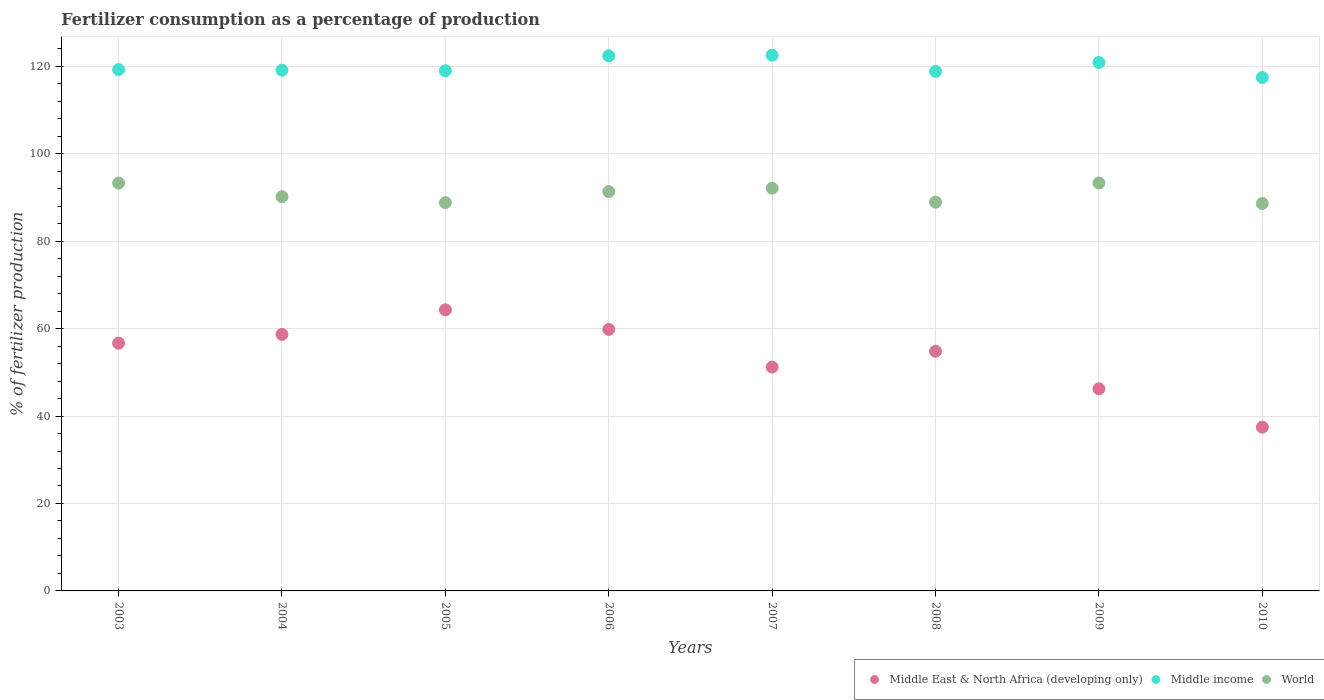Is the number of dotlines equal to the number of legend labels?
Give a very brief answer. Yes. What is the percentage of fertilizers consumed in World in 2007?
Offer a very short reply. 92.12. Across all years, what is the maximum percentage of fertilizers consumed in Middle East & North Africa (developing only)?
Your response must be concise. 64.3. Across all years, what is the minimum percentage of fertilizers consumed in Middle East & North Africa (developing only)?
Give a very brief answer. 37.45. In which year was the percentage of fertilizers consumed in Middle income maximum?
Offer a very short reply. 2007. What is the total percentage of fertilizers consumed in World in the graph?
Give a very brief answer. 726.58. What is the difference between the percentage of fertilizers consumed in World in 2003 and that in 2010?
Provide a short and direct response. 4.67. What is the difference between the percentage of fertilizers consumed in World in 2004 and the percentage of fertilizers consumed in Middle East & North Africa (developing only) in 2007?
Keep it short and to the point. 38.98. What is the average percentage of fertilizers consumed in World per year?
Your answer should be very brief. 90.82. In the year 2009, what is the difference between the percentage of fertilizers consumed in World and percentage of fertilizers consumed in Middle income?
Provide a short and direct response. -27.55. In how many years, is the percentage of fertilizers consumed in Middle East & North Africa (developing only) greater than 88 %?
Your answer should be compact. 0. What is the ratio of the percentage of fertilizers consumed in Middle East & North Africa (developing only) in 2004 to that in 2010?
Your response must be concise. 1.57. Is the percentage of fertilizers consumed in World in 2007 less than that in 2010?
Make the answer very short. No. Is the difference between the percentage of fertilizers consumed in World in 2007 and 2008 greater than the difference between the percentage of fertilizers consumed in Middle income in 2007 and 2008?
Offer a terse response. No. What is the difference between the highest and the second highest percentage of fertilizers consumed in World?
Your response must be concise. 0.04. What is the difference between the highest and the lowest percentage of fertilizers consumed in Middle East & North Africa (developing only)?
Your answer should be compact. 26.85. Does the percentage of fertilizers consumed in Middle income monotonically increase over the years?
Keep it short and to the point. No. Is the percentage of fertilizers consumed in World strictly greater than the percentage of fertilizers consumed in Middle East & North Africa (developing only) over the years?
Your response must be concise. Yes. How many dotlines are there?
Ensure brevity in your answer.  3. How many years are there in the graph?
Your answer should be very brief. 8. Does the graph contain grids?
Provide a short and direct response. Yes. How many legend labels are there?
Provide a short and direct response. 3. How are the legend labels stacked?
Your answer should be compact. Horizontal. What is the title of the graph?
Your answer should be very brief. Fertilizer consumption as a percentage of production. What is the label or title of the X-axis?
Offer a terse response. Years. What is the label or title of the Y-axis?
Provide a short and direct response. % of fertilizer production. What is the % of fertilizer production of Middle East & North Africa (developing only) in 2003?
Offer a very short reply. 56.66. What is the % of fertilizer production in Middle income in 2003?
Offer a terse response. 119.25. What is the % of fertilizer production in World in 2003?
Ensure brevity in your answer.  93.27. What is the % of fertilizer production in Middle East & North Africa (developing only) in 2004?
Make the answer very short. 58.68. What is the % of fertilizer production in Middle income in 2004?
Your answer should be compact. 119.11. What is the % of fertilizer production in World in 2004?
Give a very brief answer. 90.18. What is the % of fertilizer production in Middle East & North Africa (developing only) in 2005?
Offer a terse response. 64.3. What is the % of fertilizer production in Middle income in 2005?
Provide a succinct answer. 118.99. What is the % of fertilizer production of World in 2005?
Your answer should be compact. 88.81. What is the % of fertilizer production in Middle East & North Africa (developing only) in 2006?
Offer a very short reply. 59.82. What is the % of fertilizer production in Middle income in 2006?
Provide a succinct answer. 122.4. What is the % of fertilizer production of World in 2006?
Make the answer very short. 91.34. What is the % of fertilizer production in Middle East & North Africa (developing only) in 2007?
Offer a terse response. 51.2. What is the % of fertilizer production in Middle income in 2007?
Offer a very short reply. 122.54. What is the % of fertilizer production of World in 2007?
Provide a short and direct response. 92.12. What is the % of fertilizer production of Middle East & North Africa (developing only) in 2008?
Give a very brief answer. 54.82. What is the % of fertilizer production of Middle income in 2008?
Ensure brevity in your answer.  118.83. What is the % of fertilizer production of World in 2008?
Offer a very short reply. 88.93. What is the % of fertilizer production of Middle East & North Africa (developing only) in 2009?
Make the answer very short. 46.24. What is the % of fertilizer production of Middle income in 2009?
Ensure brevity in your answer.  120.87. What is the % of fertilizer production in World in 2009?
Offer a very short reply. 93.31. What is the % of fertilizer production of Middle East & North Africa (developing only) in 2010?
Ensure brevity in your answer.  37.45. What is the % of fertilizer production in Middle income in 2010?
Give a very brief answer. 117.44. What is the % of fertilizer production in World in 2010?
Provide a short and direct response. 88.61. Across all years, what is the maximum % of fertilizer production of Middle East & North Africa (developing only)?
Your response must be concise. 64.3. Across all years, what is the maximum % of fertilizer production in Middle income?
Your answer should be compact. 122.54. Across all years, what is the maximum % of fertilizer production in World?
Ensure brevity in your answer.  93.31. Across all years, what is the minimum % of fertilizer production in Middle East & North Africa (developing only)?
Provide a short and direct response. 37.45. Across all years, what is the minimum % of fertilizer production of Middle income?
Make the answer very short. 117.44. Across all years, what is the minimum % of fertilizer production in World?
Provide a succinct answer. 88.61. What is the total % of fertilizer production in Middle East & North Africa (developing only) in the graph?
Your response must be concise. 429.16. What is the total % of fertilizer production of Middle income in the graph?
Provide a short and direct response. 959.42. What is the total % of fertilizer production in World in the graph?
Provide a short and direct response. 726.58. What is the difference between the % of fertilizer production in Middle East & North Africa (developing only) in 2003 and that in 2004?
Your answer should be very brief. -2.02. What is the difference between the % of fertilizer production of Middle income in 2003 and that in 2004?
Your answer should be compact. 0.14. What is the difference between the % of fertilizer production in World in 2003 and that in 2004?
Ensure brevity in your answer.  3.09. What is the difference between the % of fertilizer production in Middle East & North Africa (developing only) in 2003 and that in 2005?
Ensure brevity in your answer.  -7.64. What is the difference between the % of fertilizer production in Middle income in 2003 and that in 2005?
Provide a short and direct response. 0.25. What is the difference between the % of fertilizer production of World in 2003 and that in 2005?
Offer a terse response. 4.47. What is the difference between the % of fertilizer production in Middle East & North Africa (developing only) in 2003 and that in 2006?
Provide a short and direct response. -3.16. What is the difference between the % of fertilizer production in Middle income in 2003 and that in 2006?
Provide a short and direct response. -3.15. What is the difference between the % of fertilizer production of World in 2003 and that in 2006?
Your answer should be very brief. 1.93. What is the difference between the % of fertilizer production of Middle East & North Africa (developing only) in 2003 and that in 2007?
Make the answer very short. 5.46. What is the difference between the % of fertilizer production in Middle income in 2003 and that in 2007?
Provide a short and direct response. -3.3. What is the difference between the % of fertilizer production of World in 2003 and that in 2007?
Your response must be concise. 1.15. What is the difference between the % of fertilizer production of Middle East & North Africa (developing only) in 2003 and that in 2008?
Make the answer very short. 1.84. What is the difference between the % of fertilizer production of Middle income in 2003 and that in 2008?
Your response must be concise. 0.41. What is the difference between the % of fertilizer production of World in 2003 and that in 2008?
Your answer should be compact. 4.34. What is the difference between the % of fertilizer production in Middle East & North Africa (developing only) in 2003 and that in 2009?
Keep it short and to the point. 10.42. What is the difference between the % of fertilizer production in Middle income in 2003 and that in 2009?
Your answer should be compact. -1.62. What is the difference between the % of fertilizer production of World in 2003 and that in 2009?
Provide a short and direct response. -0.04. What is the difference between the % of fertilizer production in Middle East & North Africa (developing only) in 2003 and that in 2010?
Offer a terse response. 19.21. What is the difference between the % of fertilizer production of Middle income in 2003 and that in 2010?
Offer a terse response. 1.81. What is the difference between the % of fertilizer production in World in 2003 and that in 2010?
Provide a succinct answer. 4.67. What is the difference between the % of fertilizer production in Middle East & North Africa (developing only) in 2004 and that in 2005?
Offer a terse response. -5.62. What is the difference between the % of fertilizer production in Middle income in 2004 and that in 2005?
Give a very brief answer. 0.12. What is the difference between the % of fertilizer production in World in 2004 and that in 2005?
Your answer should be very brief. 1.37. What is the difference between the % of fertilizer production in Middle East & North Africa (developing only) in 2004 and that in 2006?
Your answer should be very brief. -1.15. What is the difference between the % of fertilizer production in Middle income in 2004 and that in 2006?
Provide a short and direct response. -3.29. What is the difference between the % of fertilizer production of World in 2004 and that in 2006?
Ensure brevity in your answer.  -1.16. What is the difference between the % of fertilizer production of Middle East & North Africa (developing only) in 2004 and that in 2007?
Make the answer very short. 7.47. What is the difference between the % of fertilizer production of Middle income in 2004 and that in 2007?
Your answer should be very brief. -3.43. What is the difference between the % of fertilizer production of World in 2004 and that in 2007?
Offer a terse response. -1.94. What is the difference between the % of fertilizer production of Middle East & North Africa (developing only) in 2004 and that in 2008?
Ensure brevity in your answer.  3.86. What is the difference between the % of fertilizer production of Middle income in 2004 and that in 2008?
Your response must be concise. 0.28. What is the difference between the % of fertilizer production of World in 2004 and that in 2008?
Keep it short and to the point. 1.25. What is the difference between the % of fertilizer production of Middle East & North Africa (developing only) in 2004 and that in 2009?
Offer a terse response. 12.44. What is the difference between the % of fertilizer production in Middle income in 2004 and that in 2009?
Your response must be concise. -1.76. What is the difference between the % of fertilizer production in World in 2004 and that in 2009?
Offer a very short reply. -3.13. What is the difference between the % of fertilizer production in Middle East & North Africa (developing only) in 2004 and that in 2010?
Your answer should be compact. 21.23. What is the difference between the % of fertilizer production of Middle income in 2004 and that in 2010?
Give a very brief answer. 1.67. What is the difference between the % of fertilizer production of World in 2004 and that in 2010?
Your answer should be compact. 1.57. What is the difference between the % of fertilizer production in Middle East & North Africa (developing only) in 2005 and that in 2006?
Provide a short and direct response. 4.48. What is the difference between the % of fertilizer production in Middle income in 2005 and that in 2006?
Your answer should be very brief. -3.41. What is the difference between the % of fertilizer production in World in 2005 and that in 2006?
Ensure brevity in your answer.  -2.54. What is the difference between the % of fertilizer production in Middle East & North Africa (developing only) in 2005 and that in 2007?
Provide a succinct answer. 13.1. What is the difference between the % of fertilizer production in Middle income in 2005 and that in 2007?
Ensure brevity in your answer.  -3.55. What is the difference between the % of fertilizer production of World in 2005 and that in 2007?
Ensure brevity in your answer.  -3.32. What is the difference between the % of fertilizer production of Middle East & North Africa (developing only) in 2005 and that in 2008?
Your response must be concise. 9.48. What is the difference between the % of fertilizer production of Middle income in 2005 and that in 2008?
Keep it short and to the point. 0.16. What is the difference between the % of fertilizer production of World in 2005 and that in 2008?
Your response must be concise. -0.12. What is the difference between the % of fertilizer production of Middle East & North Africa (developing only) in 2005 and that in 2009?
Keep it short and to the point. 18.06. What is the difference between the % of fertilizer production in Middle income in 2005 and that in 2009?
Ensure brevity in your answer.  -1.87. What is the difference between the % of fertilizer production in World in 2005 and that in 2009?
Keep it short and to the point. -4.51. What is the difference between the % of fertilizer production in Middle East & North Africa (developing only) in 2005 and that in 2010?
Keep it short and to the point. 26.85. What is the difference between the % of fertilizer production in Middle income in 2005 and that in 2010?
Your response must be concise. 1.55. What is the difference between the % of fertilizer production in World in 2005 and that in 2010?
Offer a terse response. 0.2. What is the difference between the % of fertilizer production of Middle East & North Africa (developing only) in 2006 and that in 2007?
Your answer should be compact. 8.62. What is the difference between the % of fertilizer production of Middle income in 2006 and that in 2007?
Your answer should be compact. -0.14. What is the difference between the % of fertilizer production in World in 2006 and that in 2007?
Ensure brevity in your answer.  -0.78. What is the difference between the % of fertilizer production in Middle East & North Africa (developing only) in 2006 and that in 2008?
Your response must be concise. 5. What is the difference between the % of fertilizer production in Middle income in 2006 and that in 2008?
Your answer should be compact. 3.57. What is the difference between the % of fertilizer production in World in 2006 and that in 2008?
Your response must be concise. 2.41. What is the difference between the % of fertilizer production of Middle East & North Africa (developing only) in 2006 and that in 2009?
Give a very brief answer. 13.58. What is the difference between the % of fertilizer production of Middle income in 2006 and that in 2009?
Your response must be concise. 1.53. What is the difference between the % of fertilizer production of World in 2006 and that in 2009?
Ensure brevity in your answer.  -1.97. What is the difference between the % of fertilizer production of Middle East & North Africa (developing only) in 2006 and that in 2010?
Offer a terse response. 22.37. What is the difference between the % of fertilizer production of Middle income in 2006 and that in 2010?
Your answer should be compact. 4.96. What is the difference between the % of fertilizer production in World in 2006 and that in 2010?
Provide a succinct answer. 2.73. What is the difference between the % of fertilizer production in Middle East & North Africa (developing only) in 2007 and that in 2008?
Give a very brief answer. -3.61. What is the difference between the % of fertilizer production in Middle income in 2007 and that in 2008?
Provide a succinct answer. 3.71. What is the difference between the % of fertilizer production in World in 2007 and that in 2008?
Your answer should be compact. 3.19. What is the difference between the % of fertilizer production of Middle East & North Africa (developing only) in 2007 and that in 2009?
Provide a short and direct response. 4.96. What is the difference between the % of fertilizer production of Middle income in 2007 and that in 2009?
Provide a succinct answer. 1.68. What is the difference between the % of fertilizer production of World in 2007 and that in 2009?
Provide a short and direct response. -1.19. What is the difference between the % of fertilizer production of Middle East & North Africa (developing only) in 2007 and that in 2010?
Provide a succinct answer. 13.75. What is the difference between the % of fertilizer production of Middle income in 2007 and that in 2010?
Offer a terse response. 5.1. What is the difference between the % of fertilizer production of World in 2007 and that in 2010?
Your response must be concise. 3.51. What is the difference between the % of fertilizer production of Middle East & North Africa (developing only) in 2008 and that in 2009?
Your answer should be very brief. 8.58. What is the difference between the % of fertilizer production of Middle income in 2008 and that in 2009?
Make the answer very short. -2.03. What is the difference between the % of fertilizer production in World in 2008 and that in 2009?
Provide a succinct answer. -4.38. What is the difference between the % of fertilizer production in Middle East & North Africa (developing only) in 2008 and that in 2010?
Provide a succinct answer. 17.37. What is the difference between the % of fertilizer production of Middle income in 2008 and that in 2010?
Offer a terse response. 1.39. What is the difference between the % of fertilizer production of World in 2008 and that in 2010?
Ensure brevity in your answer.  0.32. What is the difference between the % of fertilizer production of Middle East & North Africa (developing only) in 2009 and that in 2010?
Provide a short and direct response. 8.79. What is the difference between the % of fertilizer production of Middle income in 2009 and that in 2010?
Your response must be concise. 3.43. What is the difference between the % of fertilizer production of World in 2009 and that in 2010?
Offer a very short reply. 4.7. What is the difference between the % of fertilizer production of Middle East & North Africa (developing only) in 2003 and the % of fertilizer production of Middle income in 2004?
Provide a succinct answer. -62.45. What is the difference between the % of fertilizer production in Middle East & North Africa (developing only) in 2003 and the % of fertilizer production in World in 2004?
Ensure brevity in your answer.  -33.52. What is the difference between the % of fertilizer production of Middle income in 2003 and the % of fertilizer production of World in 2004?
Provide a short and direct response. 29.06. What is the difference between the % of fertilizer production in Middle East & North Africa (developing only) in 2003 and the % of fertilizer production in Middle income in 2005?
Keep it short and to the point. -62.33. What is the difference between the % of fertilizer production in Middle East & North Africa (developing only) in 2003 and the % of fertilizer production in World in 2005?
Give a very brief answer. -32.15. What is the difference between the % of fertilizer production in Middle income in 2003 and the % of fertilizer production in World in 2005?
Your response must be concise. 30.44. What is the difference between the % of fertilizer production of Middle East & North Africa (developing only) in 2003 and the % of fertilizer production of Middle income in 2006?
Provide a succinct answer. -65.74. What is the difference between the % of fertilizer production in Middle East & North Africa (developing only) in 2003 and the % of fertilizer production in World in 2006?
Keep it short and to the point. -34.68. What is the difference between the % of fertilizer production of Middle income in 2003 and the % of fertilizer production of World in 2006?
Offer a very short reply. 27.9. What is the difference between the % of fertilizer production in Middle East & North Africa (developing only) in 2003 and the % of fertilizer production in Middle income in 2007?
Give a very brief answer. -65.88. What is the difference between the % of fertilizer production of Middle East & North Africa (developing only) in 2003 and the % of fertilizer production of World in 2007?
Your response must be concise. -35.47. What is the difference between the % of fertilizer production in Middle income in 2003 and the % of fertilizer production in World in 2007?
Your answer should be compact. 27.12. What is the difference between the % of fertilizer production in Middle East & North Africa (developing only) in 2003 and the % of fertilizer production in Middle income in 2008?
Your answer should be compact. -62.17. What is the difference between the % of fertilizer production in Middle East & North Africa (developing only) in 2003 and the % of fertilizer production in World in 2008?
Your response must be concise. -32.27. What is the difference between the % of fertilizer production of Middle income in 2003 and the % of fertilizer production of World in 2008?
Make the answer very short. 30.32. What is the difference between the % of fertilizer production in Middle East & North Africa (developing only) in 2003 and the % of fertilizer production in Middle income in 2009?
Make the answer very short. -64.21. What is the difference between the % of fertilizer production in Middle East & North Africa (developing only) in 2003 and the % of fertilizer production in World in 2009?
Keep it short and to the point. -36.66. What is the difference between the % of fertilizer production in Middle income in 2003 and the % of fertilizer production in World in 2009?
Ensure brevity in your answer.  25.93. What is the difference between the % of fertilizer production of Middle East & North Africa (developing only) in 2003 and the % of fertilizer production of Middle income in 2010?
Provide a succinct answer. -60.78. What is the difference between the % of fertilizer production of Middle East & North Africa (developing only) in 2003 and the % of fertilizer production of World in 2010?
Make the answer very short. -31.95. What is the difference between the % of fertilizer production of Middle income in 2003 and the % of fertilizer production of World in 2010?
Provide a short and direct response. 30.64. What is the difference between the % of fertilizer production in Middle East & North Africa (developing only) in 2004 and the % of fertilizer production in Middle income in 2005?
Offer a terse response. -60.32. What is the difference between the % of fertilizer production in Middle East & North Africa (developing only) in 2004 and the % of fertilizer production in World in 2005?
Make the answer very short. -30.13. What is the difference between the % of fertilizer production in Middle income in 2004 and the % of fertilizer production in World in 2005?
Ensure brevity in your answer.  30.3. What is the difference between the % of fertilizer production in Middle East & North Africa (developing only) in 2004 and the % of fertilizer production in Middle income in 2006?
Offer a very short reply. -63.72. What is the difference between the % of fertilizer production in Middle East & North Africa (developing only) in 2004 and the % of fertilizer production in World in 2006?
Offer a terse response. -32.67. What is the difference between the % of fertilizer production in Middle income in 2004 and the % of fertilizer production in World in 2006?
Offer a terse response. 27.77. What is the difference between the % of fertilizer production of Middle East & North Africa (developing only) in 2004 and the % of fertilizer production of Middle income in 2007?
Offer a very short reply. -63.87. What is the difference between the % of fertilizer production in Middle East & North Africa (developing only) in 2004 and the % of fertilizer production in World in 2007?
Your answer should be very brief. -33.45. What is the difference between the % of fertilizer production of Middle income in 2004 and the % of fertilizer production of World in 2007?
Ensure brevity in your answer.  26.99. What is the difference between the % of fertilizer production in Middle East & North Africa (developing only) in 2004 and the % of fertilizer production in Middle income in 2008?
Your answer should be very brief. -60.16. What is the difference between the % of fertilizer production of Middle East & North Africa (developing only) in 2004 and the % of fertilizer production of World in 2008?
Offer a terse response. -30.25. What is the difference between the % of fertilizer production in Middle income in 2004 and the % of fertilizer production in World in 2008?
Your answer should be very brief. 30.18. What is the difference between the % of fertilizer production of Middle East & North Africa (developing only) in 2004 and the % of fertilizer production of Middle income in 2009?
Your answer should be compact. -62.19. What is the difference between the % of fertilizer production in Middle East & North Africa (developing only) in 2004 and the % of fertilizer production in World in 2009?
Your answer should be compact. -34.64. What is the difference between the % of fertilizer production of Middle income in 2004 and the % of fertilizer production of World in 2009?
Your response must be concise. 25.8. What is the difference between the % of fertilizer production in Middle East & North Africa (developing only) in 2004 and the % of fertilizer production in Middle income in 2010?
Offer a terse response. -58.76. What is the difference between the % of fertilizer production of Middle East & North Africa (developing only) in 2004 and the % of fertilizer production of World in 2010?
Your answer should be very brief. -29.93. What is the difference between the % of fertilizer production of Middle income in 2004 and the % of fertilizer production of World in 2010?
Your answer should be very brief. 30.5. What is the difference between the % of fertilizer production in Middle East & North Africa (developing only) in 2005 and the % of fertilizer production in Middle income in 2006?
Your response must be concise. -58.1. What is the difference between the % of fertilizer production of Middle East & North Africa (developing only) in 2005 and the % of fertilizer production of World in 2006?
Your answer should be very brief. -27.04. What is the difference between the % of fertilizer production of Middle income in 2005 and the % of fertilizer production of World in 2006?
Give a very brief answer. 27.65. What is the difference between the % of fertilizer production in Middle East & North Africa (developing only) in 2005 and the % of fertilizer production in Middle income in 2007?
Provide a short and direct response. -58.25. What is the difference between the % of fertilizer production of Middle East & North Africa (developing only) in 2005 and the % of fertilizer production of World in 2007?
Provide a succinct answer. -27.83. What is the difference between the % of fertilizer production in Middle income in 2005 and the % of fertilizer production in World in 2007?
Make the answer very short. 26.87. What is the difference between the % of fertilizer production of Middle East & North Africa (developing only) in 2005 and the % of fertilizer production of Middle income in 2008?
Provide a short and direct response. -54.53. What is the difference between the % of fertilizer production in Middle East & North Africa (developing only) in 2005 and the % of fertilizer production in World in 2008?
Your response must be concise. -24.63. What is the difference between the % of fertilizer production in Middle income in 2005 and the % of fertilizer production in World in 2008?
Ensure brevity in your answer.  30.06. What is the difference between the % of fertilizer production of Middle East & North Africa (developing only) in 2005 and the % of fertilizer production of Middle income in 2009?
Keep it short and to the point. -56.57. What is the difference between the % of fertilizer production in Middle East & North Africa (developing only) in 2005 and the % of fertilizer production in World in 2009?
Keep it short and to the point. -29.02. What is the difference between the % of fertilizer production in Middle income in 2005 and the % of fertilizer production in World in 2009?
Provide a succinct answer. 25.68. What is the difference between the % of fertilizer production in Middle East & North Africa (developing only) in 2005 and the % of fertilizer production in Middle income in 2010?
Keep it short and to the point. -53.14. What is the difference between the % of fertilizer production of Middle East & North Africa (developing only) in 2005 and the % of fertilizer production of World in 2010?
Your answer should be very brief. -24.31. What is the difference between the % of fertilizer production of Middle income in 2005 and the % of fertilizer production of World in 2010?
Your response must be concise. 30.38. What is the difference between the % of fertilizer production of Middle East & North Africa (developing only) in 2006 and the % of fertilizer production of Middle income in 2007?
Ensure brevity in your answer.  -62.72. What is the difference between the % of fertilizer production of Middle East & North Africa (developing only) in 2006 and the % of fertilizer production of World in 2007?
Offer a terse response. -32.3. What is the difference between the % of fertilizer production of Middle income in 2006 and the % of fertilizer production of World in 2007?
Your response must be concise. 30.27. What is the difference between the % of fertilizer production in Middle East & North Africa (developing only) in 2006 and the % of fertilizer production in Middle income in 2008?
Your response must be concise. -59.01. What is the difference between the % of fertilizer production in Middle East & North Africa (developing only) in 2006 and the % of fertilizer production in World in 2008?
Offer a terse response. -29.11. What is the difference between the % of fertilizer production in Middle income in 2006 and the % of fertilizer production in World in 2008?
Give a very brief answer. 33.47. What is the difference between the % of fertilizer production of Middle East & North Africa (developing only) in 2006 and the % of fertilizer production of Middle income in 2009?
Offer a very short reply. -61.04. What is the difference between the % of fertilizer production in Middle East & North Africa (developing only) in 2006 and the % of fertilizer production in World in 2009?
Provide a short and direct response. -33.49. What is the difference between the % of fertilizer production in Middle income in 2006 and the % of fertilizer production in World in 2009?
Provide a succinct answer. 29.08. What is the difference between the % of fertilizer production in Middle East & North Africa (developing only) in 2006 and the % of fertilizer production in Middle income in 2010?
Provide a short and direct response. -57.62. What is the difference between the % of fertilizer production in Middle East & North Africa (developing only) in 2006 and the % of fertilizer production in World in 2010?
Make the answer very short. -28.79. What is the difference between the % of fertilizer production in Middle income in 2006 and the % of fertilizer production in World in 2010?
Make the answer very short. 33.79. What is the difference between the % of fertilizer production in Middle East & North Africa (developing only) in 2007 and the % of fertilizer production in Middle income in 2008?
Make the answer very short. -67.63. What is the difference between the % of fertilizer production of Middle East & North Africa (developing only) in 2007 and the % of fertilizer production of World in 2008?
Your answer should be compact. -37.73. What is the difference between the % of fertilizer production of Middle income in 2007 and the % of fertilizer production of World in 2008?
Give a very brief answer. 33.61. What is the difference between the % of fertilizer production in Middle East & North Africa (developing only) in 2007 and the % of fertilizer production in Middle income in 2009?
Your response must be concise. -69.66. What is the difference between the % of fertilizer production of Middle East & North Africa (developing only) in 2007 and the % of fertilizer production of World in 2009?
Your answer should be very brief. -42.11. What is the difference between the % of fertilizer production in Middle income in 2007 and the % of fertilizer production in World in 2009?
Give a very brief answer. 29.23. What is the difference between the % of fertilizer production of Middle East & North Africa (developing only) in 2007 and the % of fertilizer production of Middle income in 2010?
Offer a terse response. -66.24. What is the difference between the % of fertilizer production in Middle East & North Africa (developing only) in 2007 and the % of fertilizer production in World in 2010?
Give a very brief answer. -37.41. What is the difference between the % of fertilizer production in Middle income in 2007 and the % of fertilizer production in World in 2010?
Provide a succinct answer. 33.93. What is the difference between the % of fertilizer production in Middle East & North Africa (developing only) in 2008 and the % of fertilizer production in Middle income in 2009?
Make the answer very short. -66.05. What is the difference between the % of fertilizer production of Middle East & North Africa (developing only) in 2008 and the % of fertilizer production of World in 2009?
Offer a very short reply. -38.5. What is the difference between the % of fertilizer production in Middle income in 2008 and the % of fertilizer production in World in 2009?
Offer a terse response. 25.52. What is the difference between the % of fertilizer production of Middle East & North Africa (developing only) in 2008 and the % of fertilizer production of Middle income in 2010?
Keep it short and to the point. -62.62. What is the difference between the % of fertilizer production of Middle East & North Africa (developing only) in 2008 and the % of fertilizer production of World in 2010?
Make the answer very short. -33.79. What is the difference between the % of fertilizer production of Middle income in 2008 and the % of fertilizer production of World in 2010?
Keep it short and to the point. 30.22. What is the difference between the % of fertilizer production of Middle East & North Africa (developing only) in 2009 and the % of fertilizer production of Middle income in 2010?
Your answer should be compact. -71.2. What is the difference between the % of fertilizer production of Middle East & North Africa (developing only) in 2009 and the % of fertilizer production of World in 2010?
Offer a terse response. -42.37. What is the difference between the % of fertilizer production in Middle income in 2009 and the % of fertilizer production in World in 2010?
Your answer should be compact. 32.26. What is the average % of fertilizer production in Middle East & North Africa (developing only) per year?
Provide a short and direct response. 53.65. What is the average % of fertilizer production in Middle income per year?
Keep it short and to the point. 119.93. What is the average % of fertilizer production in World per year?
Offer a terse response. 90.82. In the year 2003, what is the difference between the % of fertilizer production in Middle East & North Africa (developing only) and % of fertilizer production in Middle income?
Keep it short and to the point. -62.59. In the year 2003, what is the difference between the % of fertilizer production in Middle East & North Africa (developing only) and % of fertilizer production in World?
Keep it short and to the point. -36.62. In the year 2003, what is the difference between the % of fertilizer production of Middle income and % of fertilizer production of World?
Keep it short and to the point. 25.97. In the year 2004, what is the difference between the % of fertilizer production in Middle East & North Africa (developing only) and % of fertilizer production in Middle income?
Your answer should be compact. -60.43. In the year 2004, what is the difference between the % of fertilizer production of Middle East & North Africa (developing only) and % of fertilizer production of World?
Provide a short and direct response. -31.51. In the year 2004, what is the difference between the % of fertilizer production in Middle income and % of fertilizer production in World?
Provide a short and direct response. 28.93. In the year 2005, what is the difference between the % of fertilizer production in Middle East & North Africa (developing only) and % of fertilizer production in Middle income?
Give a very brief answer. -54.69. In the year 2005, what is the difference between the % of fertilizer production in Middle East & North Africa (developing only) and % of fertilizer production in World?
Your answer should be very brief. -24.51. In the year 2005, what is the difference between the % of fertilizer production in Middle income and % of fertilizer production in World?
Your response must be concise. 30.18. In the year 2006, what is the difference between the % of fertilizer production of Middle East & North Africa (developing only) and % of fertilizer production of Middle income?
Your response must be concise. -62.58. In the year 2006, what is the difference between the % of fertilizer production of Middle East & North Africa (developing only) and % of fertilizer production of World?
Give a very brief answer. -31.52. In the year 2006, what is the difference between the % of fertilizer production in Middle income and % of fertilizer production in World?
Keep it short and to the point. 31.06. In the year 2007, what is the difference between the % of fertilizer production of Middle East & North Africa (developing only) and % of fertilizer production of Middle income?
Offer a terse response. -71.34. In the year 2007, what is the difference between the % of fertilizer production in Middle East & North Africa (developing only) and % of fertilizer production in World?
Offer a very short reply. -40.92. In the year 2007, what is the difference between the % of fertilizer production of Middle income and % of fertilizer production of World?
Provide a succinct answer. 30.42. In the year 2008, what is the difference between the % of fertilizer production of Middle East & North Africa (developing only) and % of fertilizer production of Middle income?
Offer a very short reply. -64.02. In the year 2008, what is the difference between the % of fertilizer production in Middle East & North Africa (developing only) and % of fertilizer production in World?
Ensure brevity in your answer.  -34.11. In the year 2008, what is the difference between the % of fertilizer production of Middle income and % of fertilizer production of World?
Ensure brevity in your answer.  29.9. In the year 2009, what is the difference between the % of fertilizer production of Middle East & North Africa (developing only) and % of fertilizer production of Middle income?
Make the answer very short. -74.63. In the year 2009, what is the difference between the % of fertilizer production in Middle East & North Africa (developing only) and % of fertilizer production in World?
Offer a very short reply. -47.07. In the year 2009, what is the difference between the % of fertilizer production in Middle income and % of fertilizer production in World?
Offer a terse response. 27.55. In the year 2010, what is the difference between the % of fertilizer production of Middle East & North Africa (developing only) and % of fertilizer production of Middle income?
Give a very brief answer. -79.99. In the year 2010, what is the difference between the % of fertilizer production in Middle East & North Africa (developing only) and % of fertilizer production in World?
Ensure brevity in your answer.  -51.16. In the year 2010, what is the difference between the % of fertilizer production of Middle income and % of fertilizer production of World?
Offer a terse response. 28.83. What is the ratio of the % of fertilizer production in Middle East & North Africa (developing only) in 2003 to that in 2004?
Make the answer very short. 0.97. What is the ratio of the % of fertilizer production of Middle income in 2003 to that in 2004?
Give a very brief answer. 1. What is the ratio of the % of fertilizer production in World in 2003 to that in 2004?
Offer a very short reply. 1.03. What is the ratio of the % of fertilizer production in Middle East & North Africa (developing only) in 2003 to that in 2005?
Your response must be concise. 0.88. What is the ratio of the % of fertilizer production in World in 2003 to that in 2005?
Give a very brief answer. 1.05. What is the ratio of the % of fertilizer production of Middle East & North Africa (developing only) in 2003 to that in 2006?
Ensure brevity in your answer.  0.95. What is the ratio of the % of fertilizer production of Middle income in 2003 to that in 2006?
Provide a succinct answer. 0.97. What is the ratio of the % of fertilizer production of World in 2003 to that in 2006?
Your answer should be compact. 1.02. What is the ratio of the % of fertilizer production of Middle East & North Africa (developing only) in 2003 to that in 2007?
Provide a short and direct response. 1.11. What is the ratio of the % of fertilizer production of Middle income in 2003 to that in 2007?
Ensure brevity in your answer.  0.97. What is the ratio of the % of fertilizer production of World in 2003 to that in 2007?
Provide a short and direct response. 1.01. What is the ratio of the % of fertilizer production in Middle East & North Africa (developing only) in 2003 to that in 2008?
Offer a very short reply. 1.03. What is the ratio of the % of fertilizer production of World in 2003 to that in 2008?
Your answer should be very brief. 1.05. What is the ratio of the % of fertilizer production of Middle East & North Africa (developing only) in 2003 to that in 2009?
Offer a terse response. 1.23. What is the ratio of the % of fertilizer production in Middle income in 2003 to that in 2009?
Give a very brief answer. 0.99. What is the ratio of the % of fertilizer production of Middle East & North Africa (developing only) in 2003 to that in 2010?
Ensure brevity in your answer.  1.51. What is the ratio of the % of fertilizer production in Middle income in 2003 to that in 2010?
Offer a very short reply. 1.02. What is the ratio of the % of fertilizer production in World in 2003 to that in 2010?
Your answer should be very brief. 1.05. What is the ratio of the % of fertilizer production in Middle East & North Africa (developing only) in 2004 to that in 2005?
Offer a terse response. 0.91. What is the ratio of the % of fertilizer production of World in 2004 to that in 2005?
Provide a succinct answer. 1.02. What is the ratio of the % of fertilizer production of Middle East & North Africa (developing only) in 2004 to that in 2006?
Give a very brief answer. 0.98. What is the ratio of the % of fertilizer production of Middle income in 2004 to that in 2006?
Provide a short and direct response. 0.97. What is the ratio of the % of fertilizer production in World in 2004 to that in 2006?
Ensure brevity in your answer.  0.99. What is the ratio of the % of fertilizer production in Middle East & North Africa (developing only) in 2004 to that in 2007?
Keep it short and to the point. 1.15. What is the ratio of the % of fertilizer production in Middle income in 2004 to that in 2007?
Keep it short and to the point. 0.97. What is the ratio of the % of fertilizer production of World in 2004 to that in 2007?
Your response must be concise. 0.98. What is the ratio of the % of fertilizer production of Middle East & North Africa (developing only) in 2004 to that in 2008?
Provide a short and direct response. 1.07. What is the ratio of the % of fertilizer production of World in 2004 to that in 2008?
Your answer should be compact. 1.01. What is the ratio of the % of fertilizer production of Middle East & North Africa (developing only) in 2004 to that in 2009?
Give a very brief answer. 1.27. What is the ratio of the % of fertilizer production in Middle income in 2004 to that in 2009?
Your answer should be very brief. 0.99. What is the ratio of the % of fertilizer production of World in 2004 to that in 2009?
Keep it short and to the point. 0.97. What is the ratio of the % of fertilizer production of Middle East & North Africa (developing only) in 2004 to that in 2010?
Your response must be concise. 1.57. What is the ratio of the % of fertilizer production of Middle income in 2004 to that in 2010?
Your response must be concise. 1.01. What is the ratio of the % of fertilizer production in World in 2004 to that in 2010?
Your answer should be very brief. 1.02. What is the ratio of the % of fertilizer production in Middle East & North Africa (developing only) in 2005 to that in 2006?
Provide a succinct answer. 1.07. What is the ratio of the % of fertilizer production in Middle income in 2005 to that in 2006?
Provide a short and direct response. 0.97. What is the ratio of the % of fertilizer production in World in 2005 to that in 2006?
Give a very brief answer. 0.97. What is the ratio of the % of fertilizer production in Middle East & North Africa (developing only) in 2005 to that in 2007?
Your response must be concise. 1.26. What is the ratio of the % of fertilizer production in World in 2005 to that in 2007?
Ensure brevity in your answer.  0.96. What is the ratio of the % of fertilizer production in Middle East & North Africa (developing only) in 2005 to that in 2008?
Ensure brevity in your answer.  1.17. What is the ratio of the % of fertilizer production in World in 2005 to that in 2008?
Ensure brevity in your answer.  1. What is the ratio of the % of fertilizer production of Middle East & North Africa (developing only) in 2005 to that in 2009?
Offer a very short reply. 1.39. What is the ratio of the % of fertilizer production in Middle income in 2005 to that in 2009?
Your answer should be very brief. 0.98. What is the ratio of the % of fertilizer production of World in 2005 to that in 2009?
Offer a terse response. 0.95. What is the ratio of the % of fertilizer production in Middle East & North Africa (developing only) in 2005 to that in 2010?
Offer a terse response. 1.72. What is the ratio of the % of fertilizer production in Middle income in 2005 to that in 2010?
Give a very brief answer. 1.01. What is the ratio of the % of fertilizer production in World in 2005 to that in 2010?
Provide a succinct answer. 1. What is the ratio of the % of fertilizer production of Middle East & North Africa (developing only) in 2006 to that in 2007?
Give a very brief answer. 1.17. What is the ratio of the % of fertilizer production of World in 2006 to that in 2007?
Make the answer very short. 0.99. What is the ratio of the % of fertilizer production of Middle East & North Africa (developing only) in 2006 to that in 2008?
Offer a terse response. 1.09. What is the ratio of the % of fertilizer production of Middle income in 2006 to that in 2008?
Ensure brevity in your answer.  1.03. What is the ratio of the % of fertilizer production of World in 2006 to that in 2008?
Your response must be concise. 1.03. What is the ratio of the % of fertilizer production in Middle East & North Africa (developing only) in 2006 to that in 2009?
Make the answer very short. 1.29. What is the ratio of the % of fertilizer production of Middle income in 2006 to that in 2009?
Your response must be concise. 1.01. What is the ratio of the % of fertilizer production in World in 2006 to that in 2009?
Make the answer very short. 0.98. What is the ratio of the % of fertilizer production in Middle East & North Africa (developing only) in 2006 to that in 2010?
Provide a succinct answer. 1.6. What is the ratio of the % of fertilizer production in Middle income in 2006 to that in 2010?
Your answer should be very brief. 1.04. What is the ratio of the % of fertilizer production in World in 2006 to that in 2010?
Your answer should be very brief. 1.03. What is the ratio of the % of fertilizer production of Middle East & North Africa (developing only) in 2007 to that in 2008?
Make the answer very short. 0.93. What is the ratio of the % of fertilizer production of Middle income in 2007 to that in 2008?
Your answer should be compact. 1.03. What is the ratio of the % of fertilizer production of World in 2007 to that in 2008?
Give a very brief answer. 1.04. What is the ratio of the % of fertilizer production of Middle East & North Africa (developing only) in 2007 to that in 2009?
Your answer should be very brief. 1.11. What is the ratio of the % of fertilizer production of Middle income in 2007 to that in 2009?
Your answer should be compact. 1.01. What is the ratio of the % of fertilizer production of World in 2007 to that in 2009?
Provide a short and direct response. 0.99. What is the ratio of the % of fertilizer production of Middle East & North Africa (developing only) in 2007 to that in 2010?
Provide a short and direct response. 1.37. What is the ratio of the % of fertilizer production of Middle income in 2007 to that in 2010?
Provide a succinct answer. 1.04. What is the ratio of the % of fertilizer production in World in 2007 to that in 2010?
Your response must be concise. 1.04. What is the ratio of the % of fertilizer production of Middle East & North Africa (developing only) in 2008 to that in 2009?
Keep it short and to the point. 1.19. What is the ratio of the % of fertilizer production in Middle income in 2008 to that in 2009?
Ensure brevity in your answer.  0.98. What is the ratio of the % of fertilizer production of World in 2008 to that in 2009?
Provide a succinct answer. 0.95. What is the ratio of the % of fertilizer production of Middle East & North Africa (developing only) in 2008 to that in 2010?
Keep it short and to the point. 1.46. What is the ratio of the % of fertilizer production in Middle income in 2008 to that in 2010?
Ensure brevity in your answer.  1.01. What is the ratio of the % of fertilizer production in Middle East & North Africa (developing only) in 2009 to that in 2010?
Your answer should be very brief. 1.23. What is the ratio of the % of fertilizer production in Middle income in 2009 to that in 2010?
Provide a succinct answer. 1.03. What is the ratio of the % of fertilizer production in World in 2009 to that in 2010?
Provide a short and direct response. 1.05. What is the difference between the highest and the second highest % of fertilizer production of Middle East & North Africa (developing only)?
Your response must be concise. 4.48. What is the difference between the highest and the second highest % of fertilizer production of Middle income?
Offer a very short reply. 0.14. What is the difference between the highest and the second highest % of fertilizer production of World?
Your answer should be very brief. 0.04. What is the difference between the highest and the lowest % of fertilizer production of Middle East & North Africa (developing only)?
Provide a succinct answer. 26.85. What is the difference between the highest and the lowest % of fertilizer production in Middle income?
Offer a very short reply. 5.1. What is the difference between the highest and the lowest % of fertilizer production of World?
Ensure brevity in your answer.  4.7. 